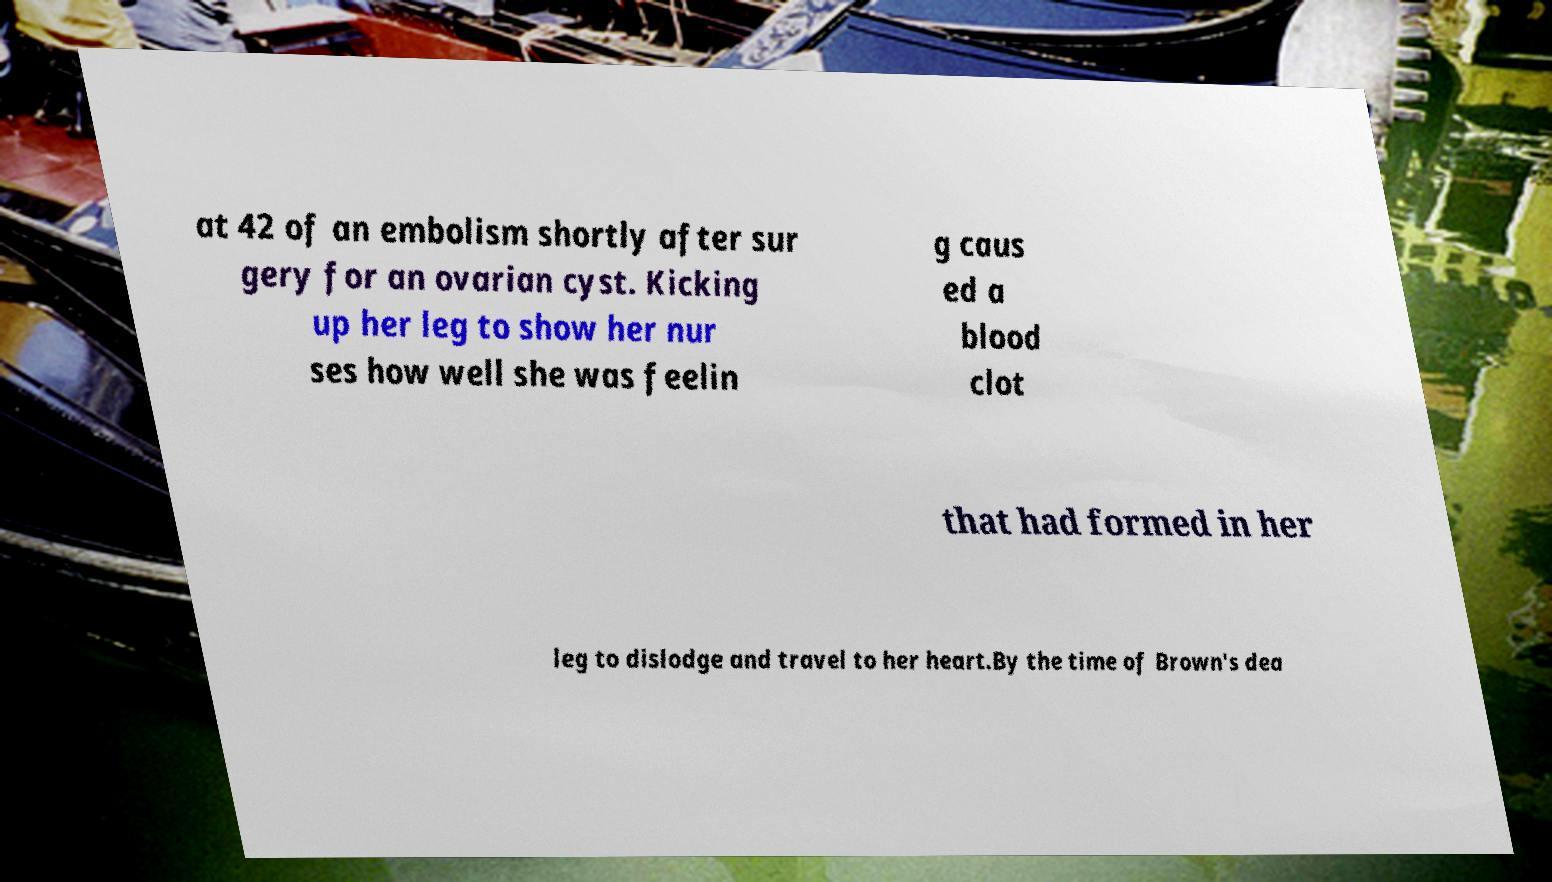Can you read and provide the text displayed in the image?This photo seems to have some interesting text. Can you extract and type it out for me? at 42 of an embolism shortly after sur gery for an ovarian cyst. Kicking up her leg to show her nur ses how well she was feelin g caus ed a blood clot that had formed in her leg to dislodge and travel to her heart.By the time of Brown's dea 